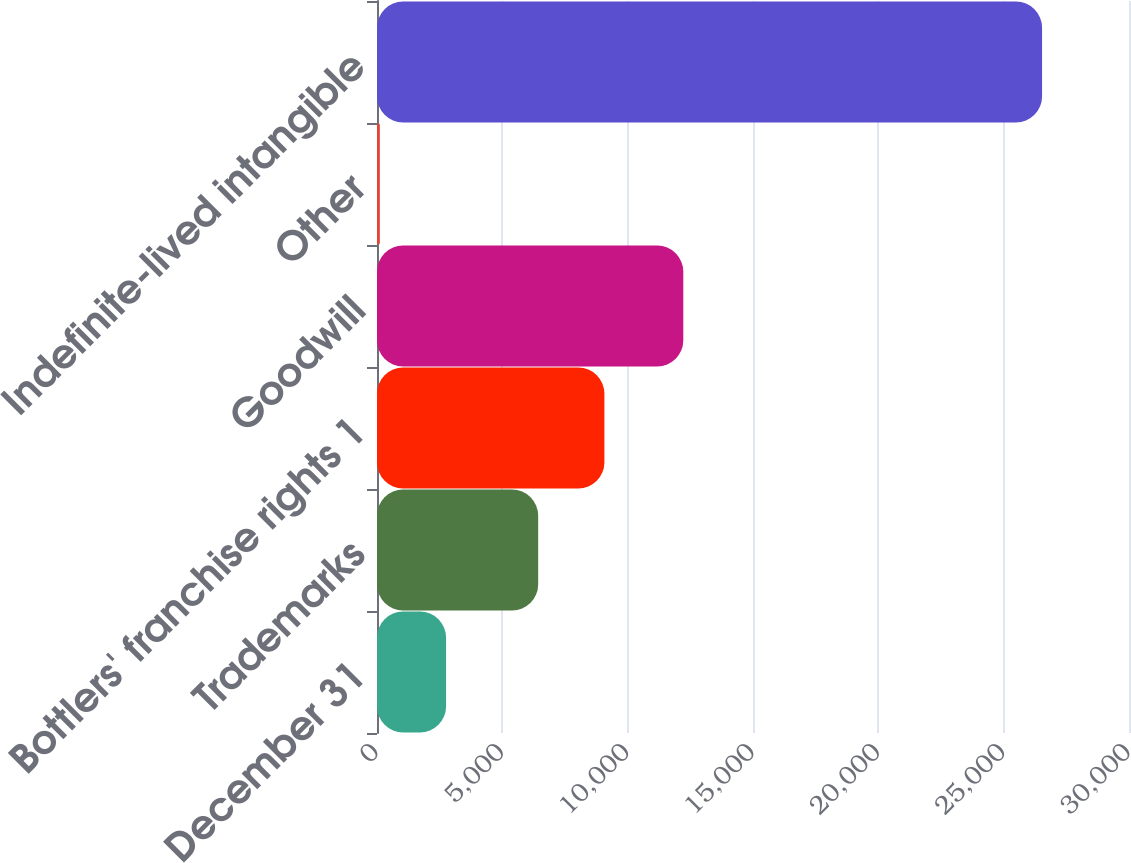Convert chart to OTSL. <chart><loc_0><loc_0><loc_500><loc_500><bar_chart><fcel>December 31<fcel>Trademarks<fcel>Bottlers' franchise rights 1<fcel>Goodwill<fcel>Other<fcel>Indefinite-lived intangible<nl><fcel>2754.9<fcel>6430<fcel>9071.9<fcel>12219<fcel>113<fcel>26532<nl></chart> 